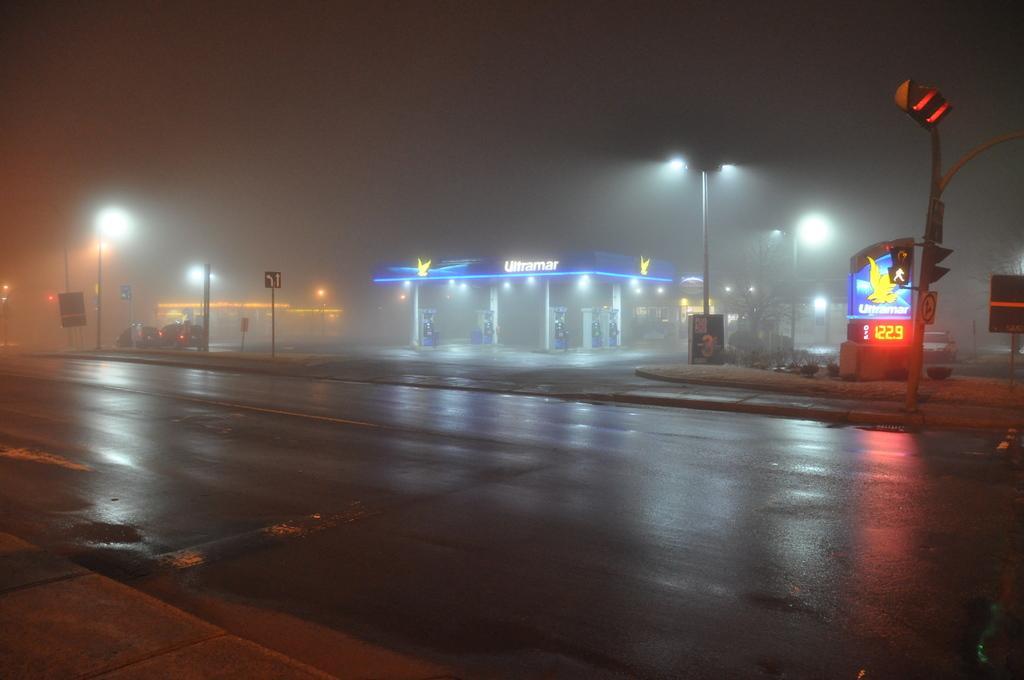Can you describe this image briefly? In this image, there is a fuel station in between street poles. There is a signal pole beside the road. There is a sky at the top of the image. 